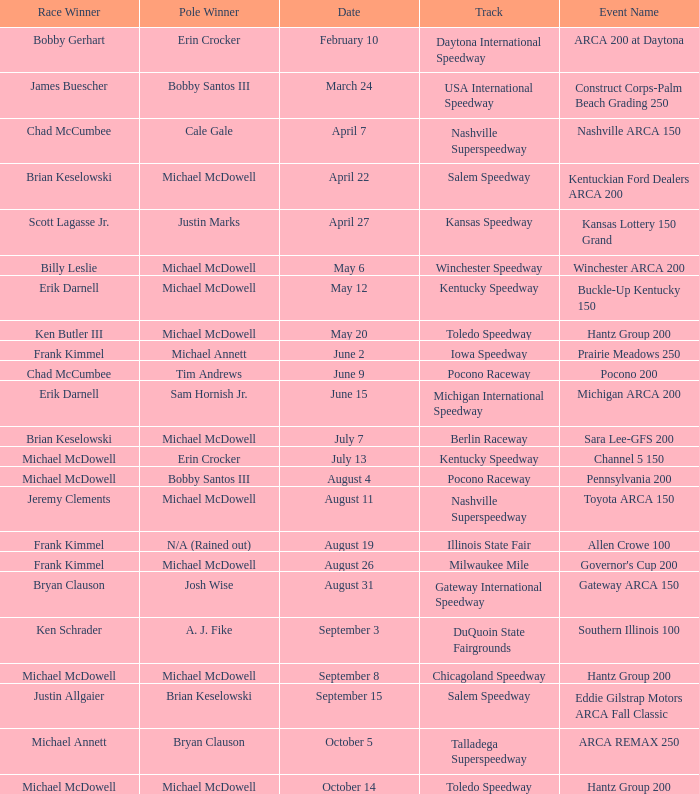Tell me the pole winner of may 12 Michael McDowell. 